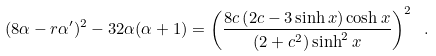<formula> <loc_0><loc_0><loc_500><loc_500>( 8 \alpha - r \alpha ^ { \prime } ) ^ { 2 } - 3 2 \alpha ( \alpha + 1 ) = \left ( \frac { 8 c \left ( 2 c - 3 \sinh x \right ) \cosh x } { \left ( 2 + c ^ { 2 } \right ) \sinh ^ { 2 } x } \right ) ^ { 2 } \ .</formula> 